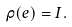<formula> <loc_0><loc_0><loc_500><loc_500>\rho ( e ) = I .</formula> 